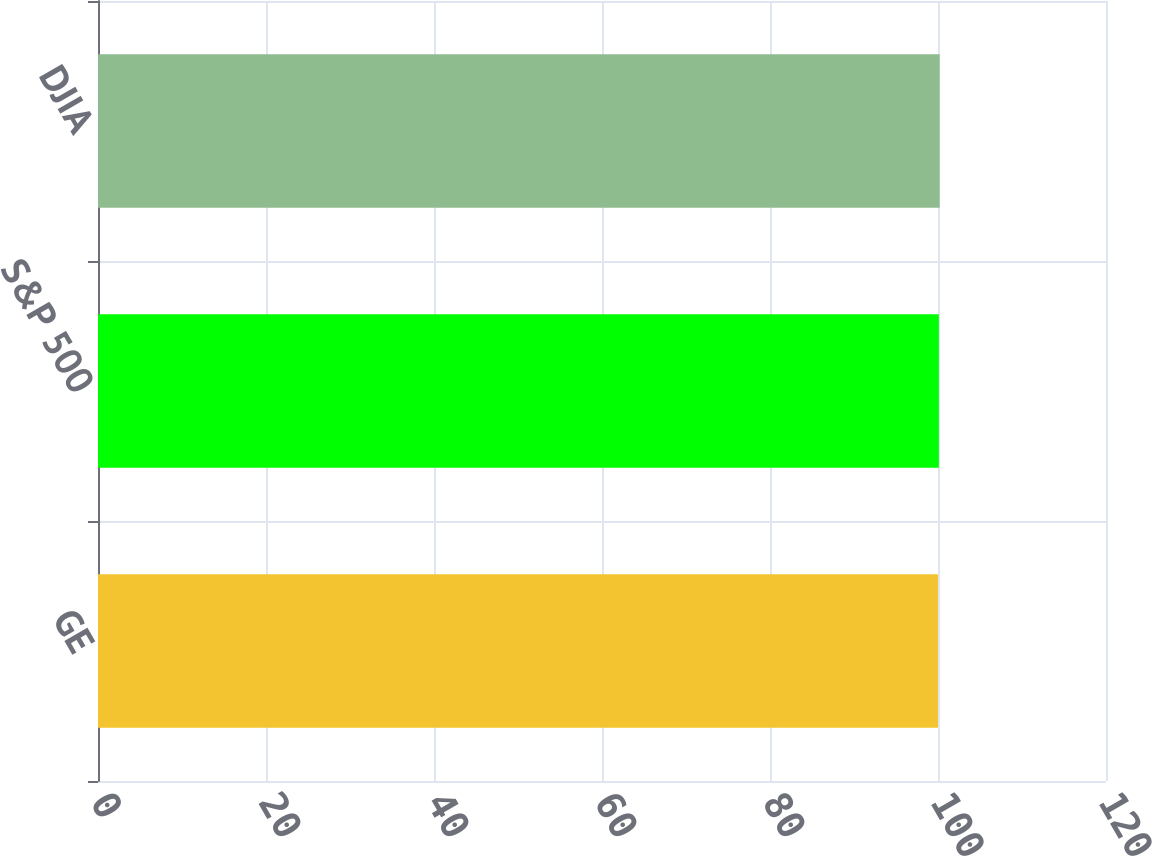Convert chart to OTSL. <chart><loc_0><loc_0><loc_500><loc_500><bar_chart><fcel>GE<fcel>S&P 500<fcel>DJIA<nl><fcel>100<fcel>100.1<fcel>100.2<nl></chart> 